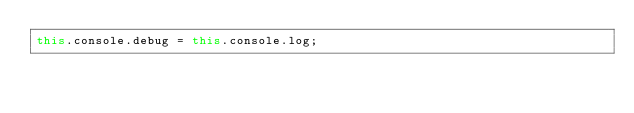<code> <loc_0><loc_0><loc_500><loc_500><_JavaScript_>this.console.debug = this.console.log;
</code> 